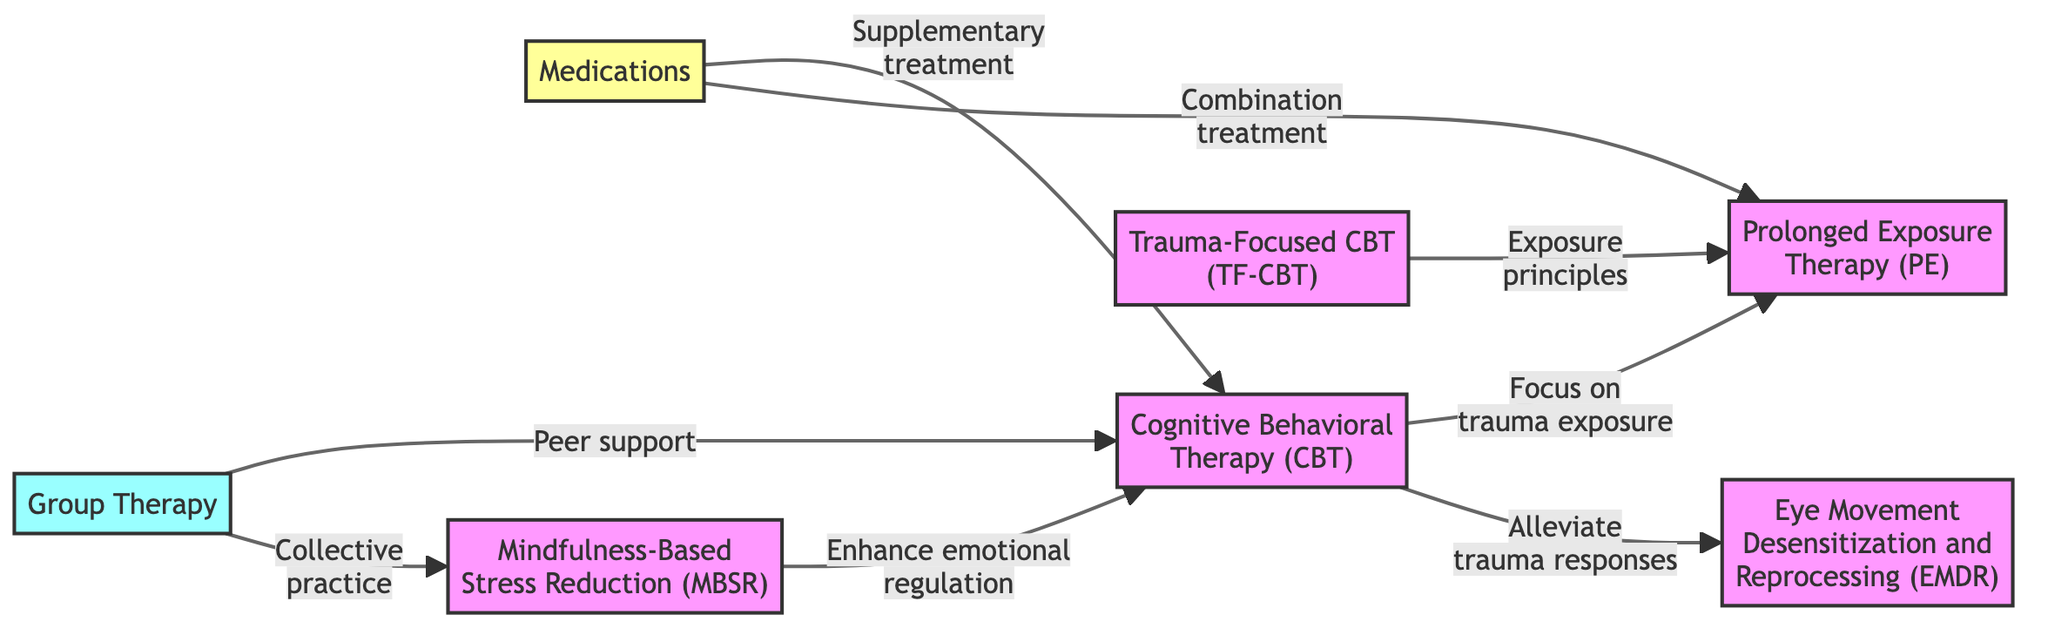What is the total number of nodes in the diagram? The diagram lists the nodes representing various intervention strategies for PTSD. By counting each unique node listed, we find a total of seven distinct nodes involved.
Answer: 7 Which therapy is connected to both Cognitive Behavioral Therapy and Prolonged Exposure Therapy? The edges specified show relationships between nodes. By examining the connections, it shows that Prolonged Exposure Therapy has a direct connection to both Cognitive Behavioral Therapy and Trauma-Focused Cognitive Behavioral Therapy.
Answer: Trauma-Focused Cognitive Behavioral Therapy What label is associated with the edge from Medications to Cognitive Behavioral Therapy? The diagram highlights a specific relationship between Medications and Cognitive Behavioral Therapy. The edge label clearly indicates the role of Medications as a "Supplementary treatment."
Answer: Supplementary treatment How many edges connect to Mindfulness-Based Stress Reduction in the diagram? By reviewing the connections for Mindfulness-Based Stress Reduction, I see it is linked to two different therapies: Cognitive Behavioral Therapy and Group Therapy. Thus, it has a total of two edges.
Answer: 2 What does the edge from Group Therapy to Mindfulness represent? The relationship shown between Group Therapy and Mindfulness indicates a connection labeled "Collective practice," suggesting a collaborative approach in the group setting for mindfulness activities.
Answer: Collective practice Which type of therapy serves as a supplementary treatment to Prolonged Exposure Therapy? The examination of edges reveals that Medications is identified as a combination treatment along with Prolonged Exposure Therapy. Therefore, it plays a role in treating PTSD alongside this therapy.
Answer: Medications What is the primary focus of Cognitive Behavioral Therapy as it relates to Prolonged Exposure Therapy? The edge from Cognitive Behavioral Therapy to Prolonged Exposure Therapy states "Focus on trauma exposure," indicating that CBT's primary focus is on addressing the concept of trauma exposure directly in relation to PE.
Answer: Focus on trauma exposure How does Mindfulness interact with Cognitive Behavioral Therapy? Mindfulness is connected to Cognitive Behavioral Therapy with the labeling "Enhance emotional regulation," suggesting that Mindfulness practices support and improve the emotional regulation in CBT processes.
Answer: Enhance emotional regulation 